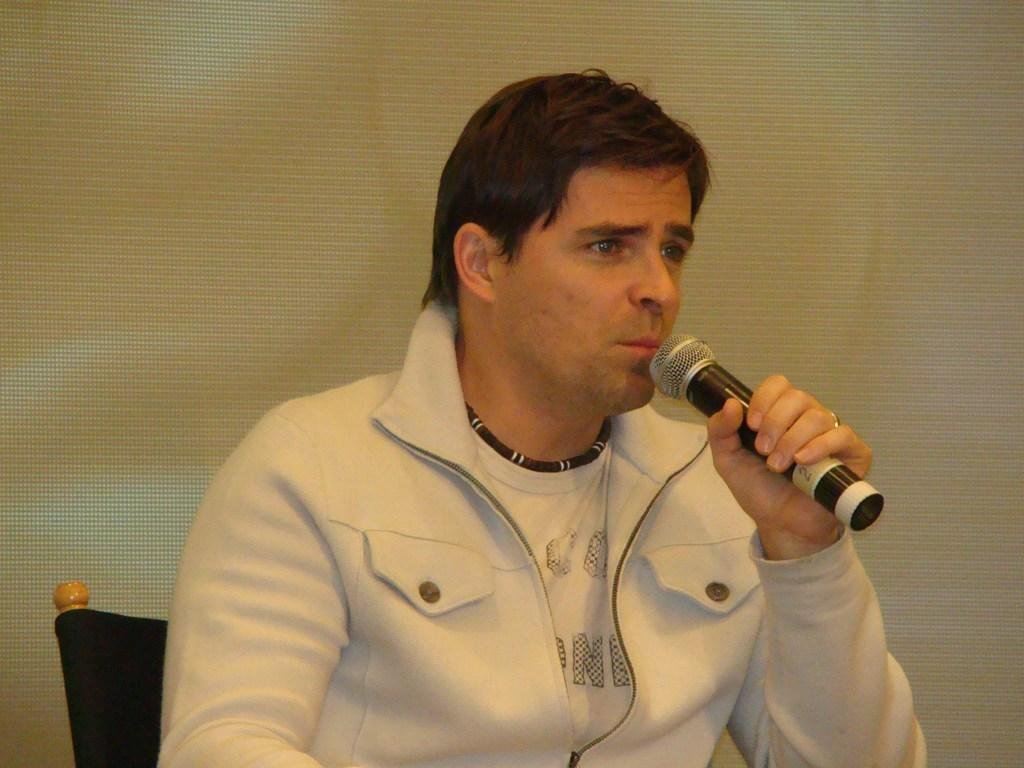Who is present in the image? There is a man in the image. What is the man doing in the image? The man is sitting in a chair. What object is the man holding in his hand? The man is holding a microphone in his hand. What type of thumbnail is visible on the man's shirt in the image? There is no thumbnail visible on the man's shirt in the image. 